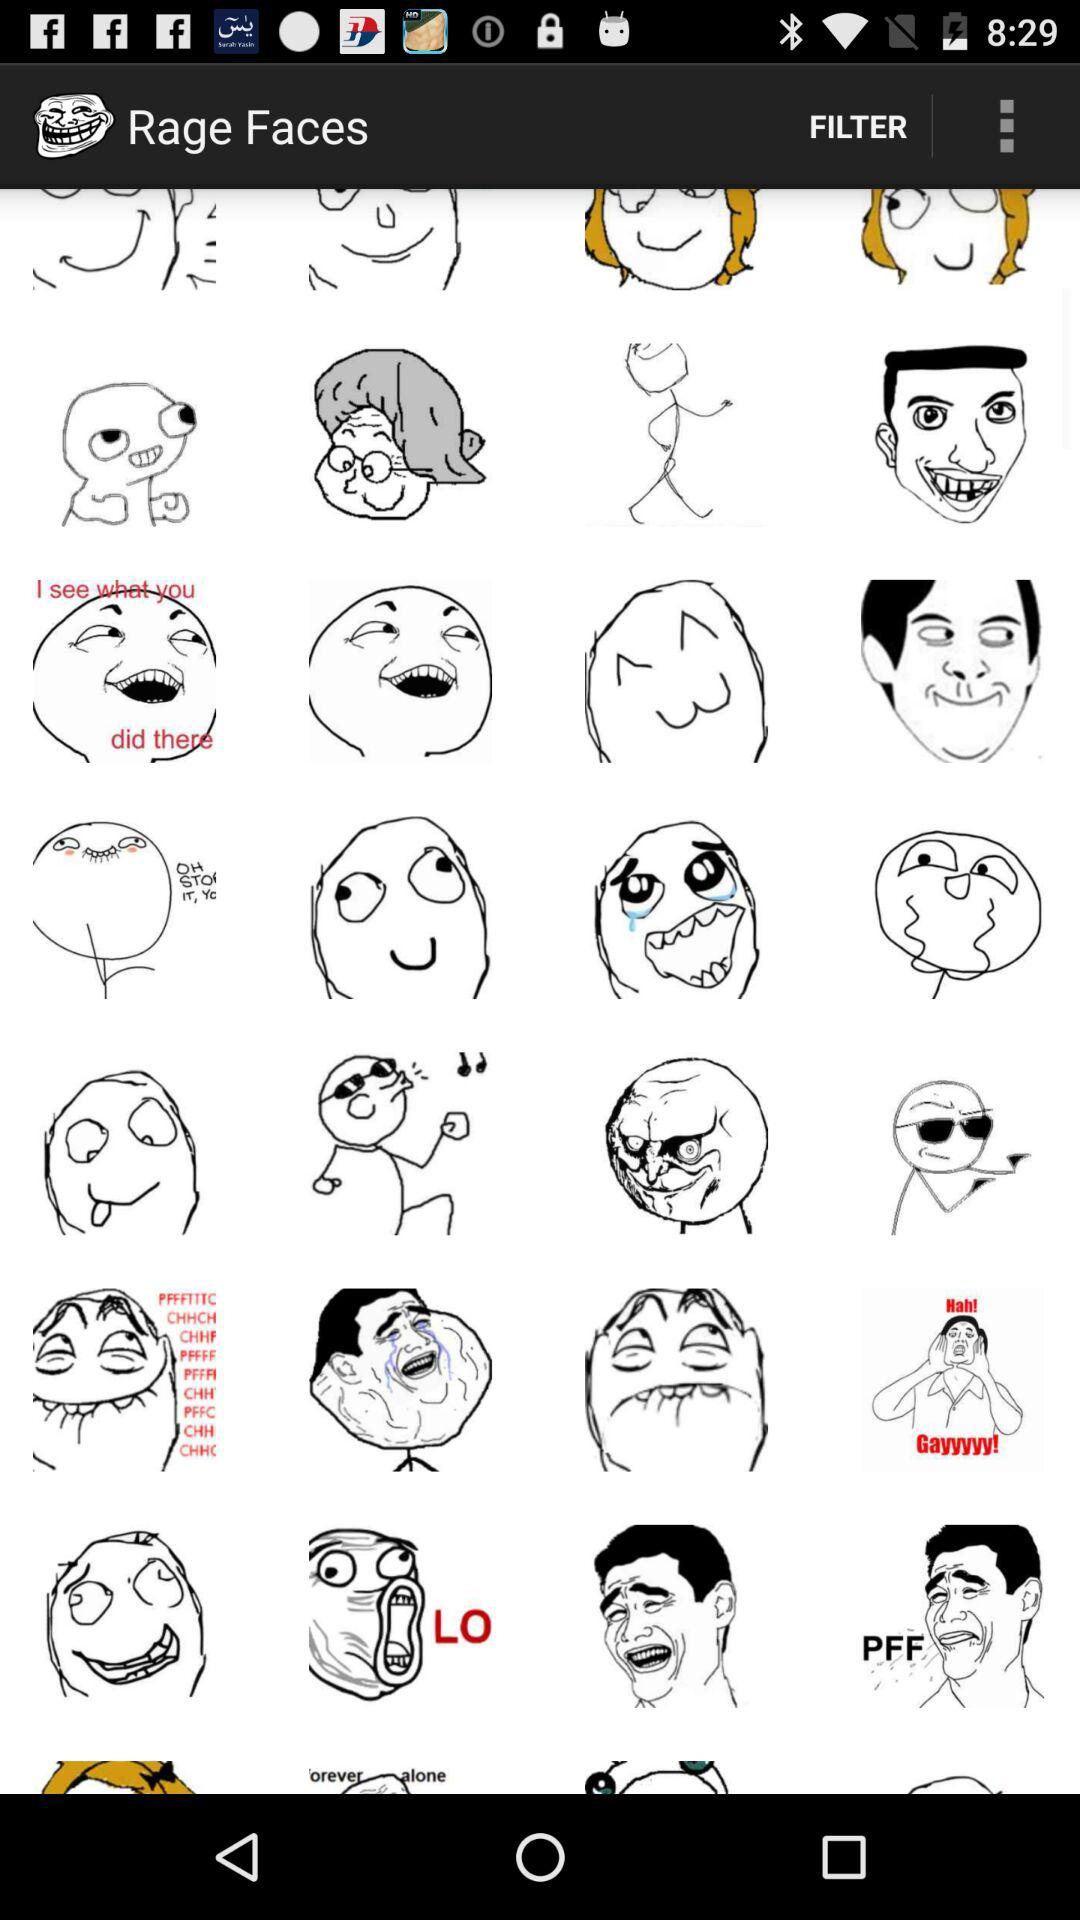How many filters are available?
When the provided information is insufficient, respond with <no answer>. <no answer> 